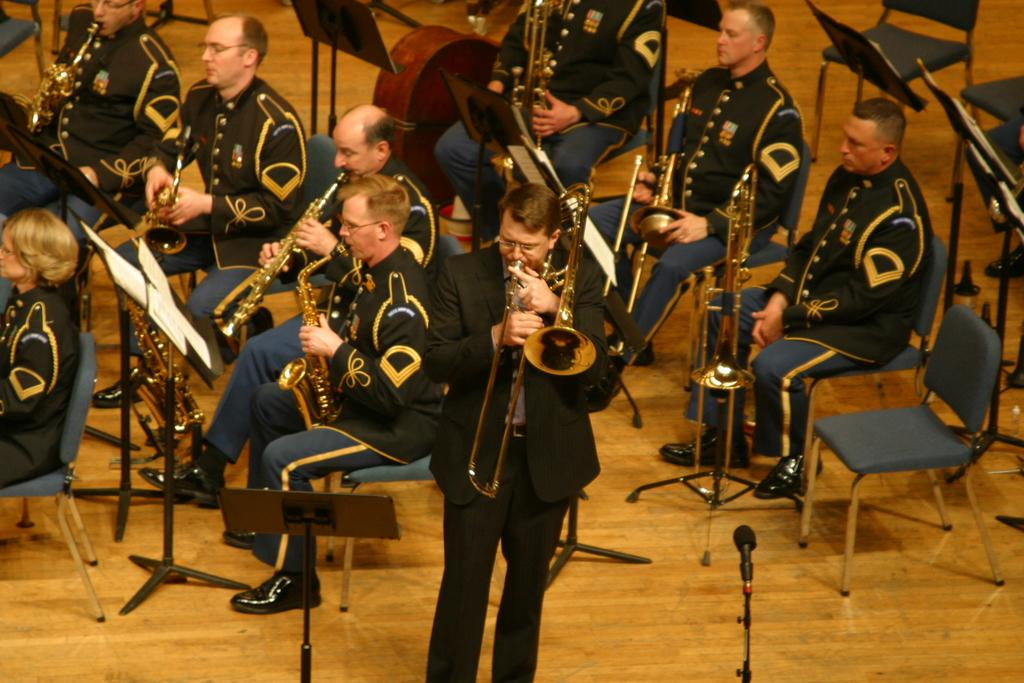How many people are in the image? There is a group of people in the image. What are the people doing in the image? The people are sitting on chairs, and one person is standing. What musical instruments can be seen in the image? There are saxophones in the image. What equipment is present for amplifying sound? There is a microphone in the image. What objects are used to hold papers in the image? There are stands with papers in the image. How many ladybugs are crawling on the saxophones in the image? There are no ladybugs present in the image; only saxophones, a microphone, and stands with papers can be seen. What type of hammer is being used by the person standing in the image? There is no hammer present in the image; the person standing is not holding or using any tool. 